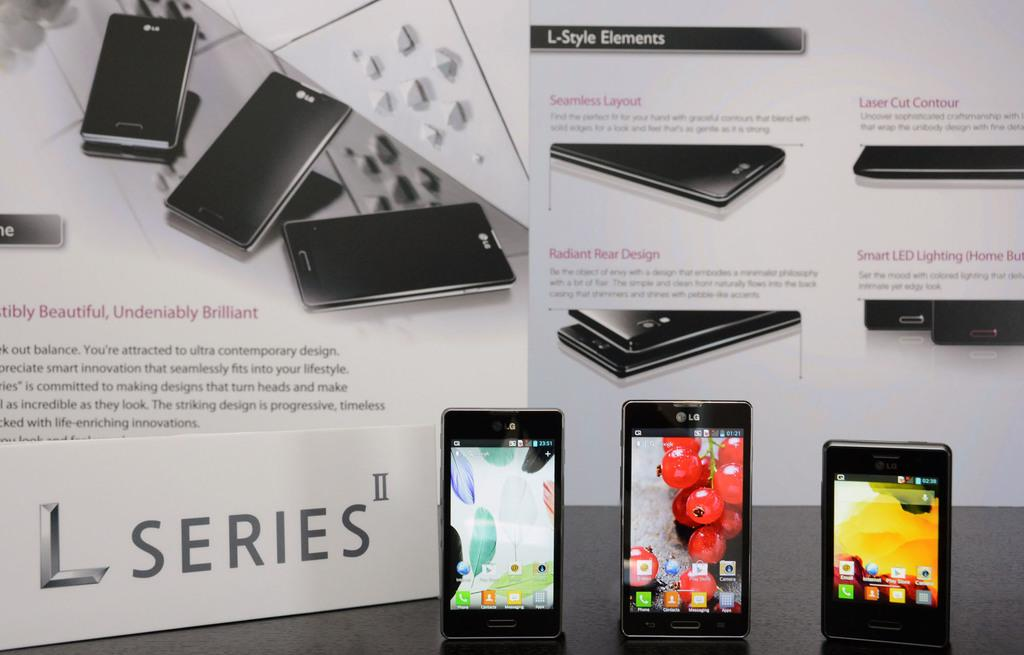<image>
Share a concise interpretation of the image provided. The new L series of cell phones 3 phones shown 